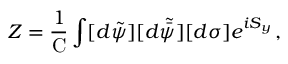<formula> <loc_0><loc_0><loc_500><loc_500>Z = \frac { 1 } { C } \int [ d \tilde { \psi } ] [ d \tilde { \bar { \psi } } ] [ d \sigma ] e ^ { i S _ { y } } \, ,</formula> 